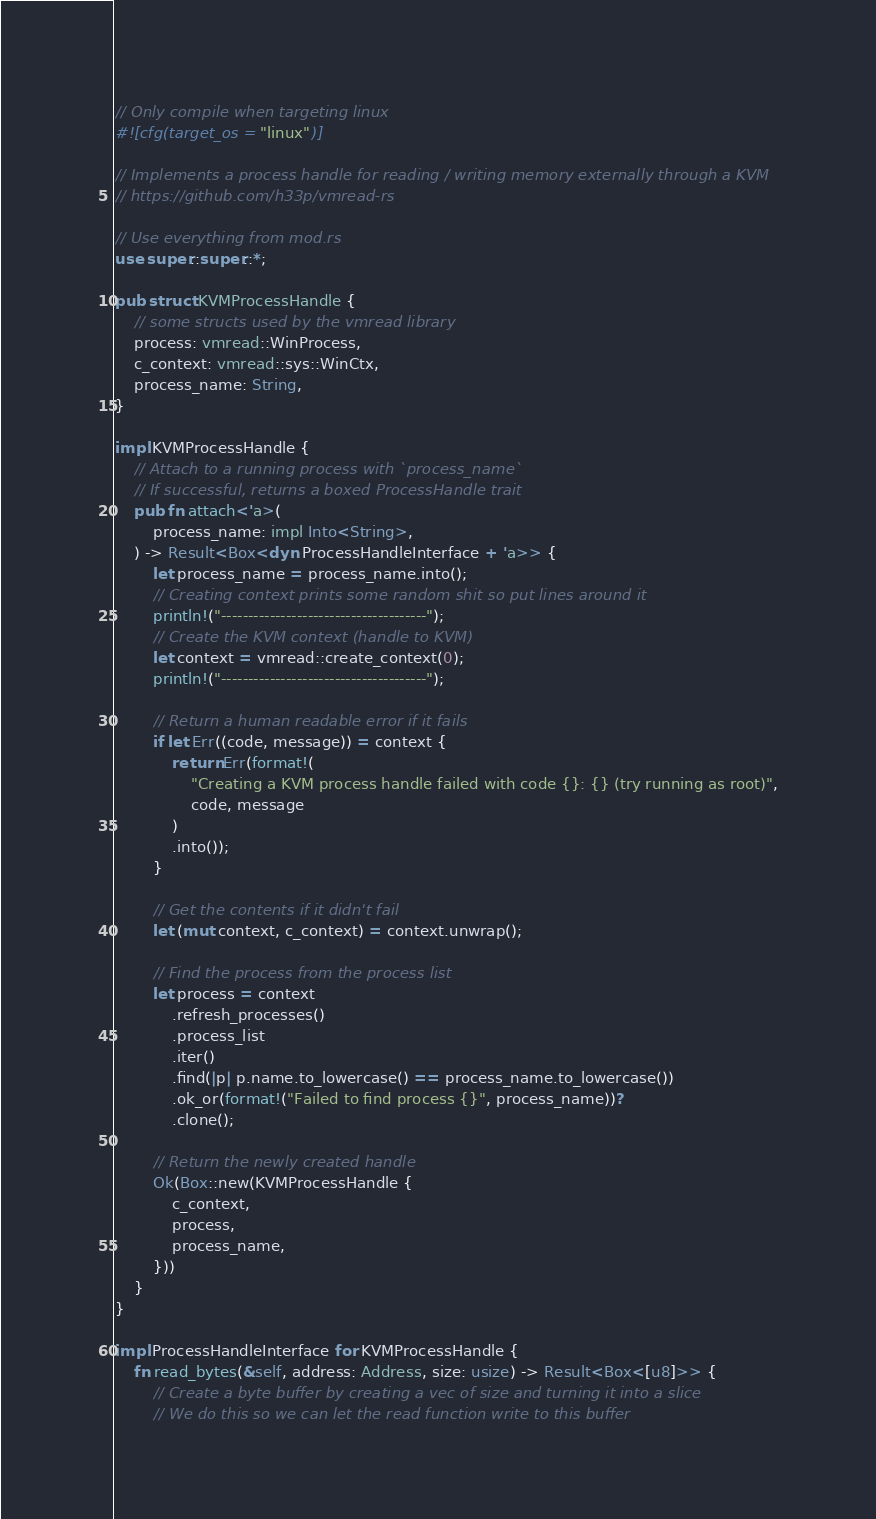<code> <loc_0><loc_0><loc_500><loc_500><_Rust_>// Only compile when targeting linux
#![cfg(target_os = "linux")]

// Implements a process handle for reading / writing memory externally through a KVM
// https://github.com/h33p/vmread-rs

// Use everything from mod.rs
use super::super::*;

pub struct KVMProcessHandle {
    // some structs used by the vmread library
    process: vmread::WinProcess,
    c_context: vmread::sys::WinCtx,
    process_name: String,
}

impl KVMProcessHandle {
    // Attach to a running process with `process_name`
    // If successful, returns a boxed ProcessHandle trait
    pub fn attach<'a>(
        process_name: impl Into<String>,
    ) -> Result<Box<dyn ProcessHandleInterface + 'a>> {
        let process_name = process_name.into();
        // Creating context prints some random shit so put lines around it
        println!("--------------------------------------");
        // Create the KVM context (handle to KVM)
        let context = vmread::create_context(0);
        println!("--------------------------------------");

        // Return a human readable error if it fails
        if let Err((code, message)) = context {
            return Err(format!(
                "Creating a KVM process handle failed with code {}: {} (try running as root)",
                code, message
            )
            .into());
        }

        // Get the contents if it didn't fail
        let (mut context, c_context) = context.unwrap();

        // Find the process from the process list
        let process = context
            .refresh_processes()
            .process_list
            .iter()
            .find(|p| p.name.to_lowercase() == process_name.to_lowercase())
            .ok_or(format!("Failed to find process {}", process_name))?
            .clone();

        // Return the newly created handle
        Ok(Box::new(KVMProcessHandle {
            c_context,
            process,
            process_name,
        }))
    }
}

impl ProcessHandleInterface for KVMProcessHandle {
    fn read_bytes(&self, address: Address, size: usize) -> Result<Box<[u8]>> {
        // Create a byte buffer by creating a vec of size and turning it into a slice
        // We do this so we can let the read function write to this buffer</code> 